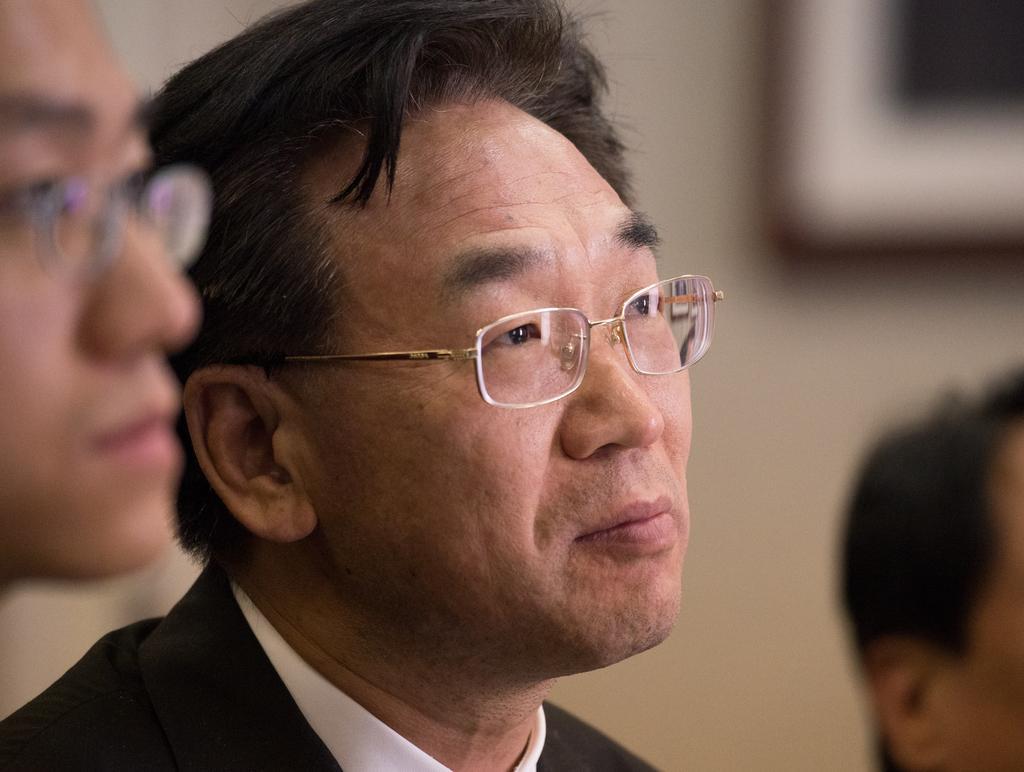Can you describe this image briefly? In the image we can see a man in the middle of them image, wearing clothes and spectacles. Beside him there are other people sitting and the background is blurred. 